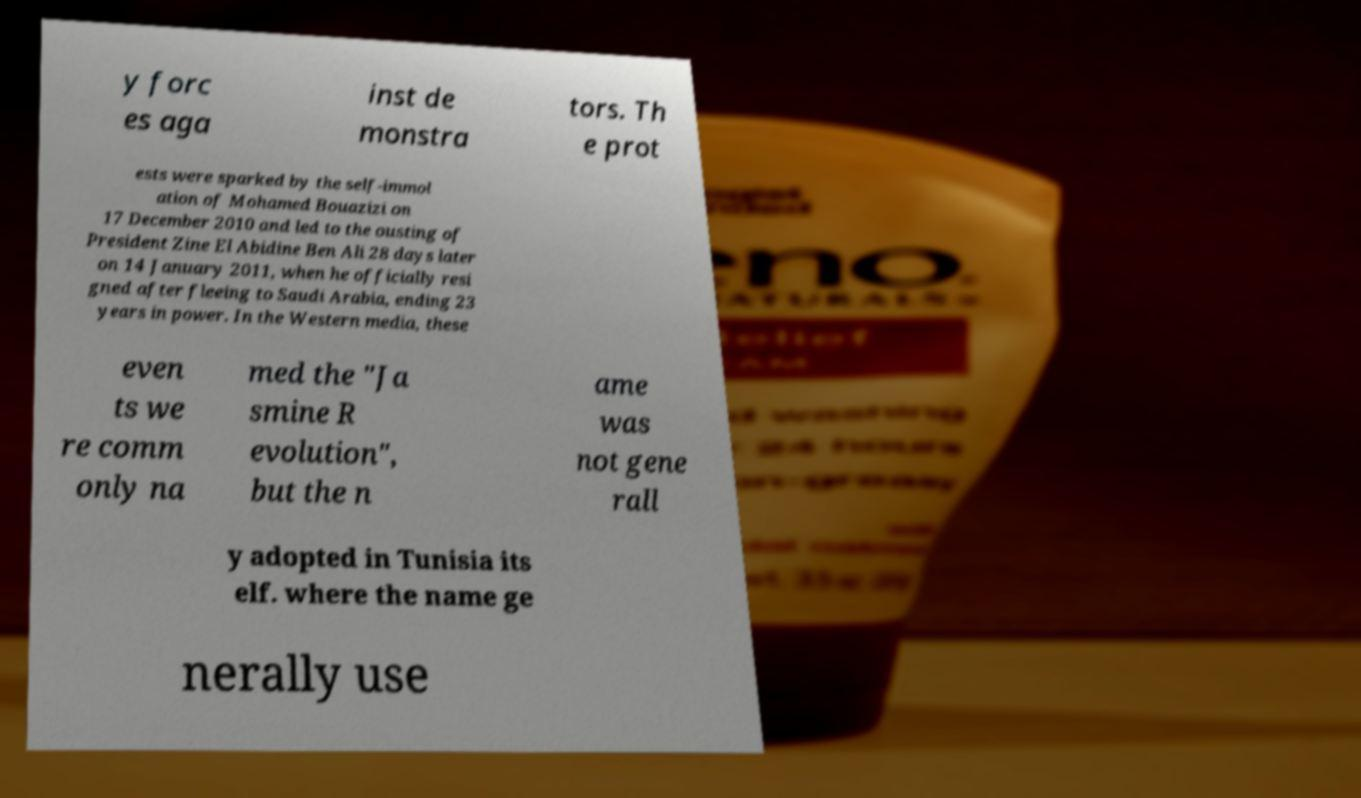I need the written content from this picture converted into text. Can you do that? y forc es aga inst de monstra tors. Th e prot ests were sparked by the self-immol ation of Mohamed Bouazizi on 17 December 2010 and led to the ousting of President Zine El Abidine Ben Ali 28 days later on 14 January 2011, when he officially resi gned after fleeing to Saudi Arabia, ending 23 years in power. In the Western media, these even ts we re comm only na med the "Ja smine R evolution", but the n ame was not gene rall y adopted in Tunisia its elf. where the name ge nerally use 